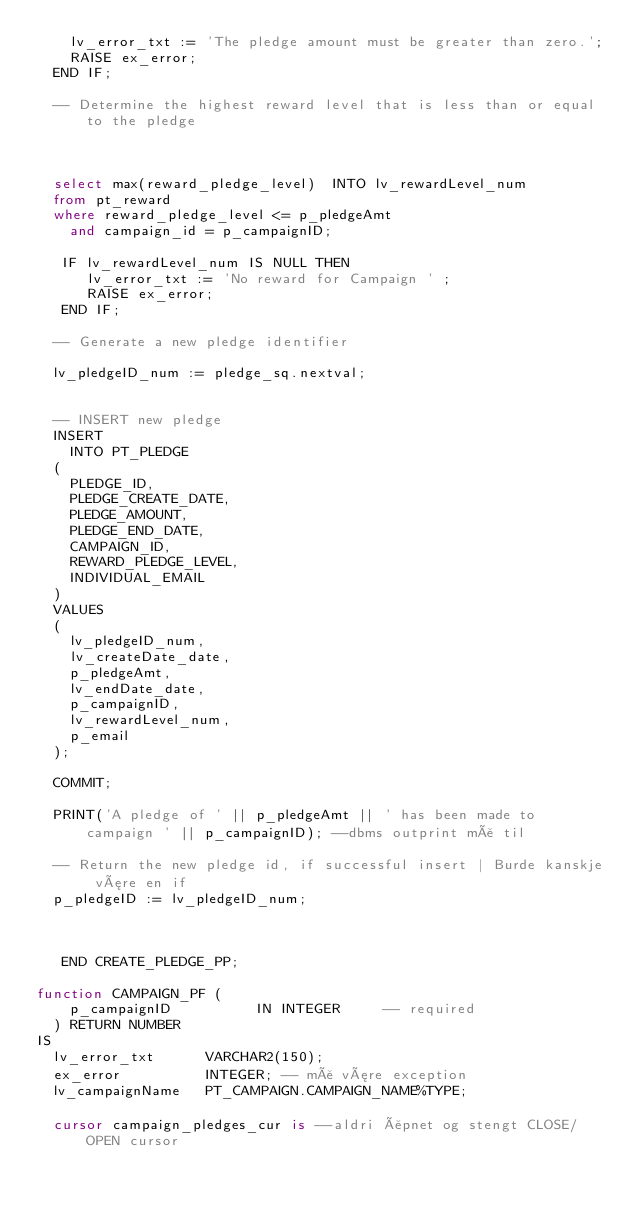<code> <loc_0><loc_0><loc_500><loc_500><_SQL_>    lv_error_txt := 'The pledge amount must be greater than zero.';
    RAISE ex_error;
  END IF;
   
  -- Determine the highest reward level that is less than or equal to the pledge
   
 
 
  select max(reward_pledge_level)  INTO lv_rewardLevel_num
  from pt_reward
  where reward_pledge_level <= p_pledgeAmt
    and campaign_id = p_campaignID;
     
   IF lv_rewardLevel_num IS NULL THEN                          
      lv_error_txt := 'No reward for Campaign ' ;  
      RAISE ex_error;
   END IF;   
   
  -- Generate a new pledge identifier
   
  lv_pledgeID_num := pledge_sq.nextval;
   
   
  -- INSERT new pledge
  INSERT
    INTO PT_PLEDGE
  (
    PLEDGE_ID,
    PLEDGE_CREATE_DATE,
    PLEDGE_AMOUNT,
    PLEDGE_END_DATE,
    CAMPAIGN_ID,
    REWARD_PLEDGE_LEVEL,
    INDIVIDUAL_EMAIL
  )
  VALUES
  (
    lv_pledgeID_num,
    lv_createDate_date,
    p_pledgeAmt,
    lv_endDate_date,
    p_campaignID,
    lv_rewardLevel_num,
    p_email
  );
   
  COMMIT;
   
  PRINT('A pledge of ' || p_pledgeAmt || ' has been made to campaign ' || p_campaignID); --dbms outprint må til
   
  -- Return the new pledge id, if successful insert | Burde kanskje være en if
  p_pledgeID := lv_pledgeID_num;
   
 
  
   END CREATE_PLEDGE_PP;
   
function CAMPAIGN_PF (
    p_campaignID          IN INTEGER     -- required
  ) RETURN NUMBER
IS
  lv_error_txt      VARCHAR2(150);
  ex_error          INTEGER; -- må være exception
  lv_campaignName   PT_CAMPAIGN.CAMPAIGN_NAME%TYPE;
   
  cursor campaign_pledges_cur is --aldri åpnet og stengt CLOSE/OPEN cursor</code> 